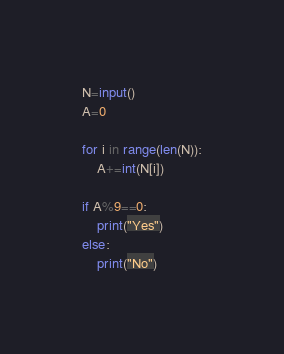<code> <loc_0><loc_0><loc_500><loc_500><_Python_>N=input()
A=0

for i in range(len(N)):
    A+=int(N[i])

if A%9==0:
    print("Yes")
else:
    print("No")</code> 